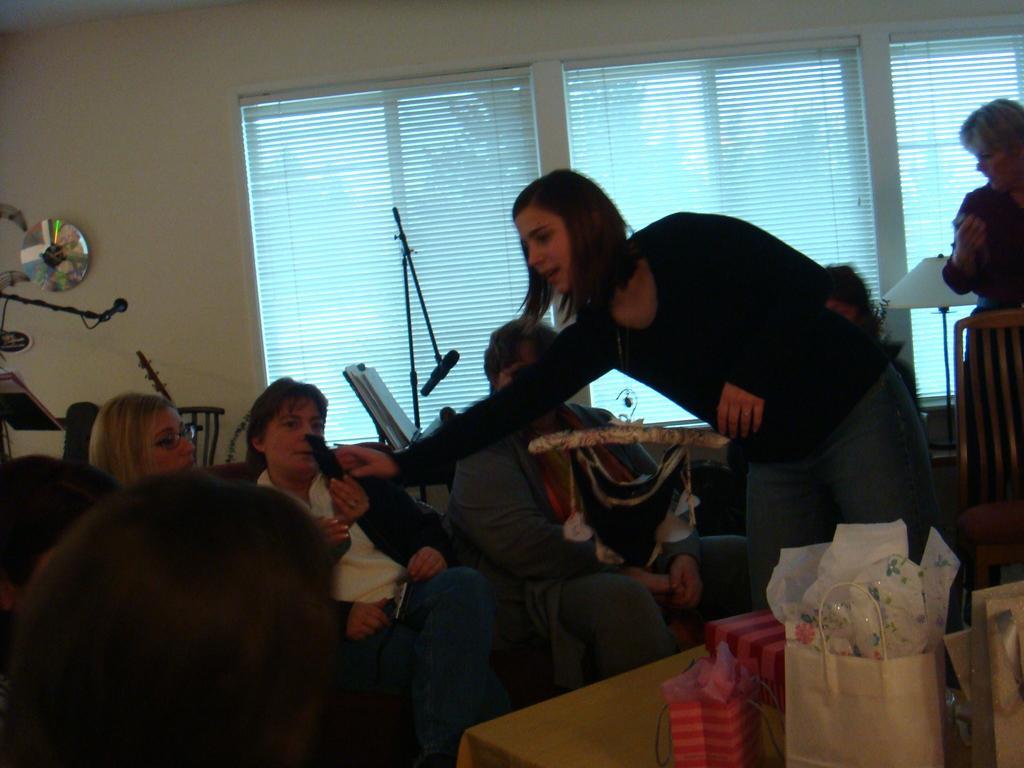Can you describe this image briefly? In this image there are people sitting and there are two people standing. Image also consists of bags on the table, mic stand. In the background we can see windows. Wall is also visible. 